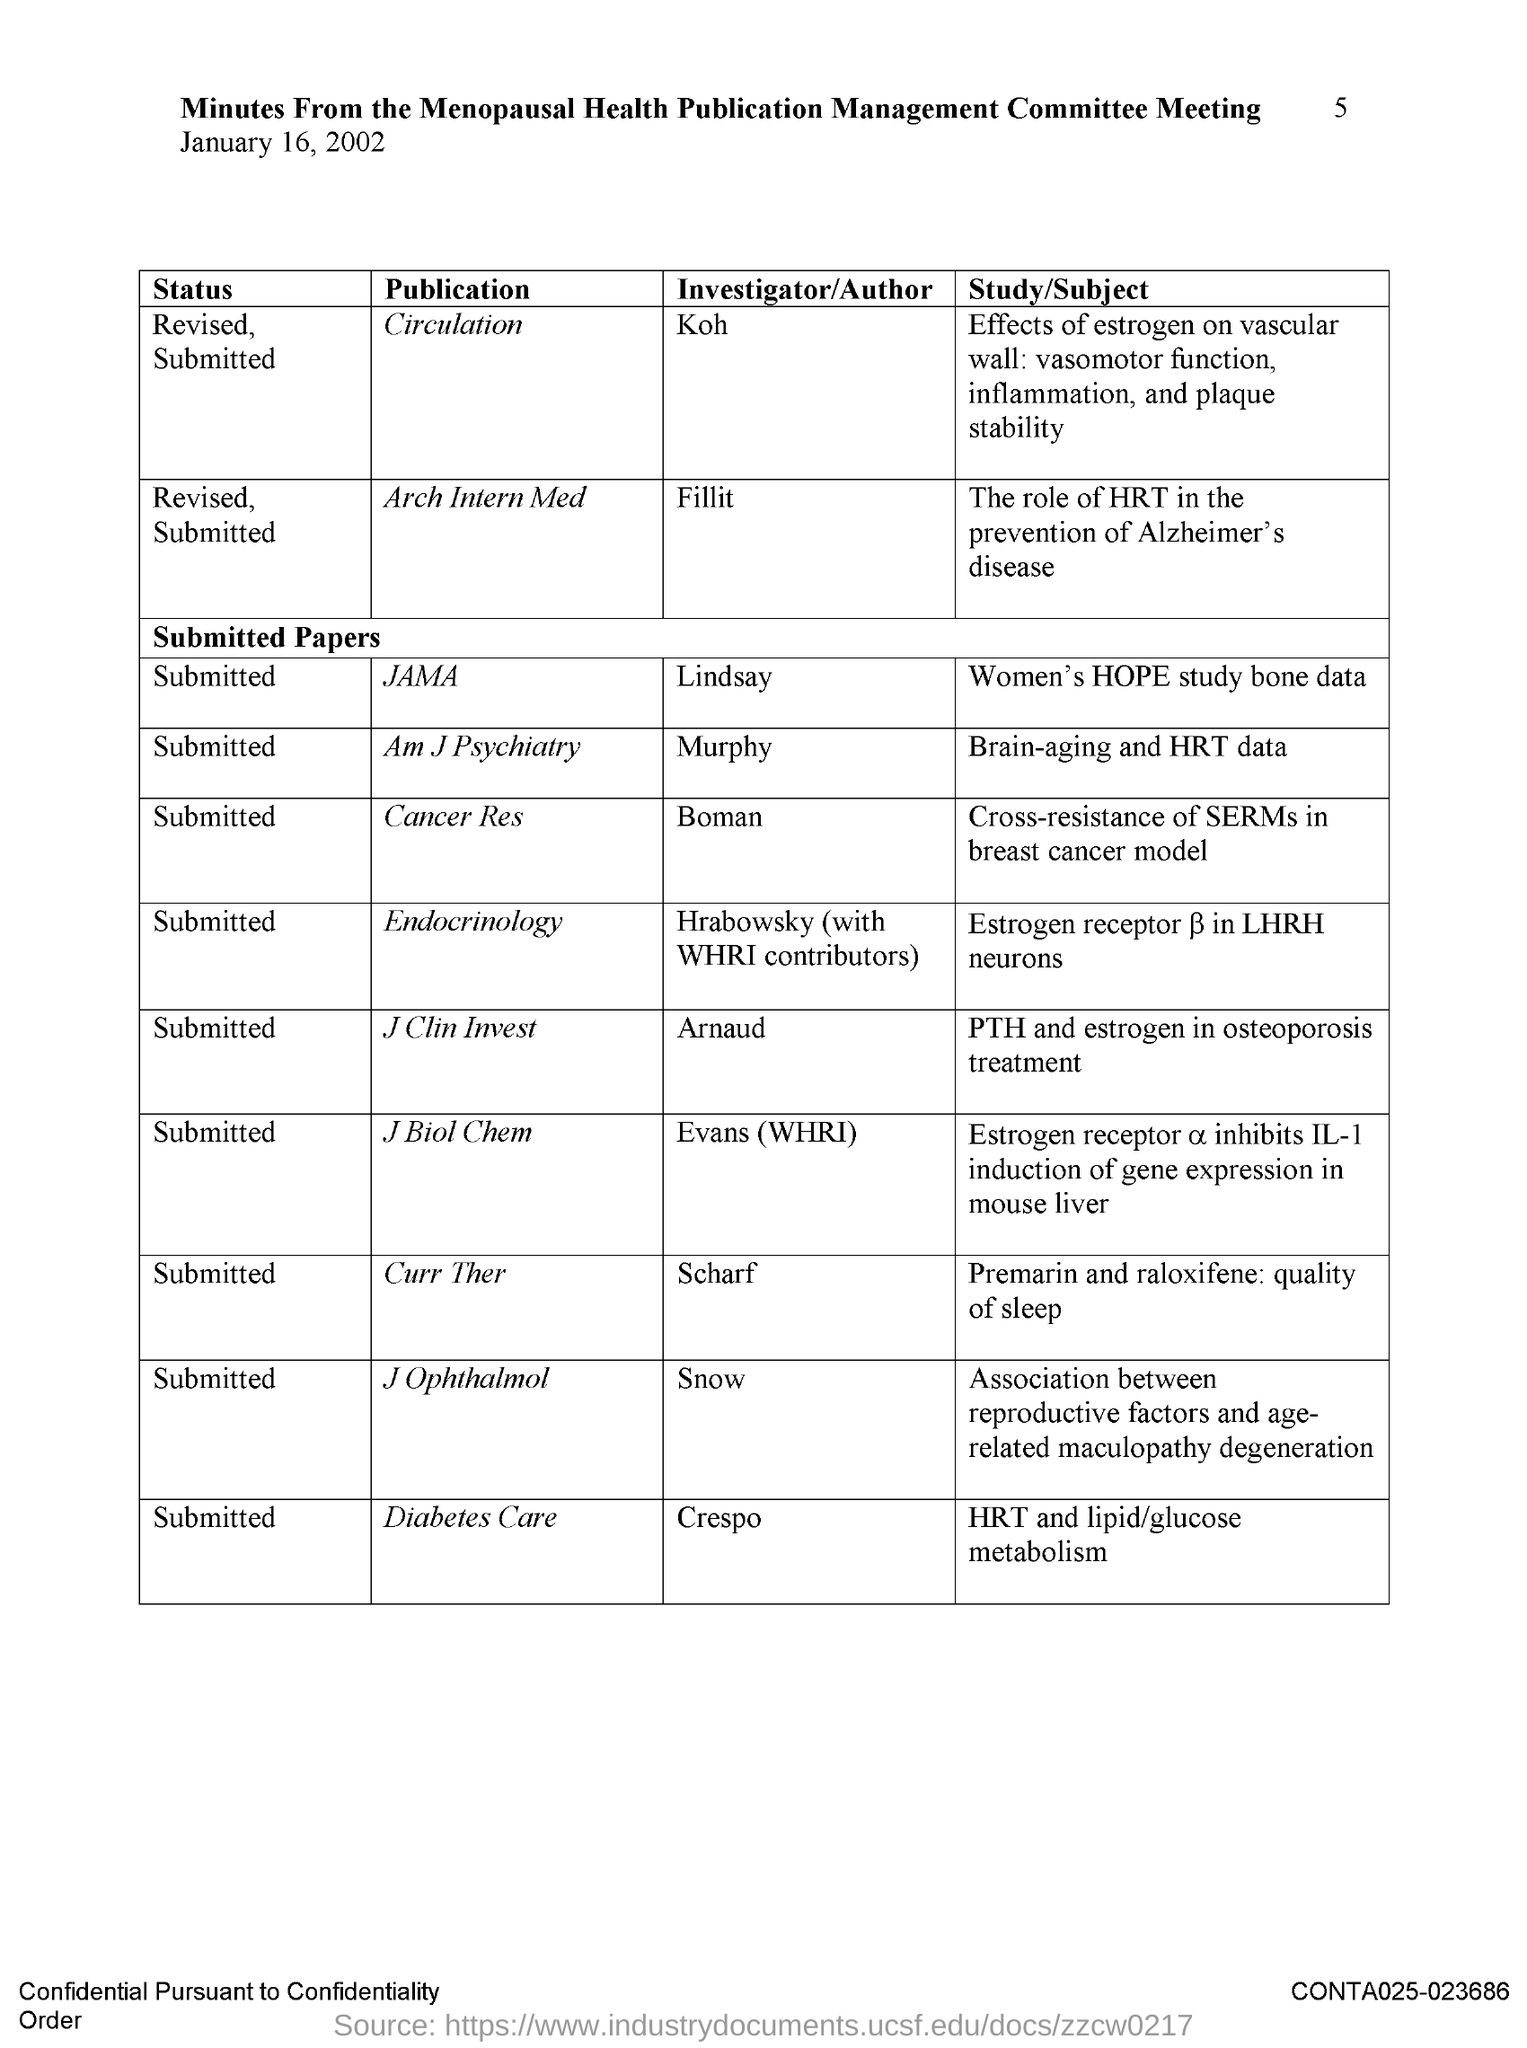Identify some key points in this picture. The investigator/author of the Arch Intern Med publication is named Filli. The name of the investigator/author for the Diabetes Care publication is Crespo. The name of the investigator/author for the JAMA publication is Lindsay. The name of the investigator or author for the current publication is Scharf. The name of the investigator/author for the Cancer Research publication is Boman. 